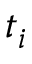<formula> <loc_0><loc_0><loc_500><loc_500>t _ { i }</formula> 